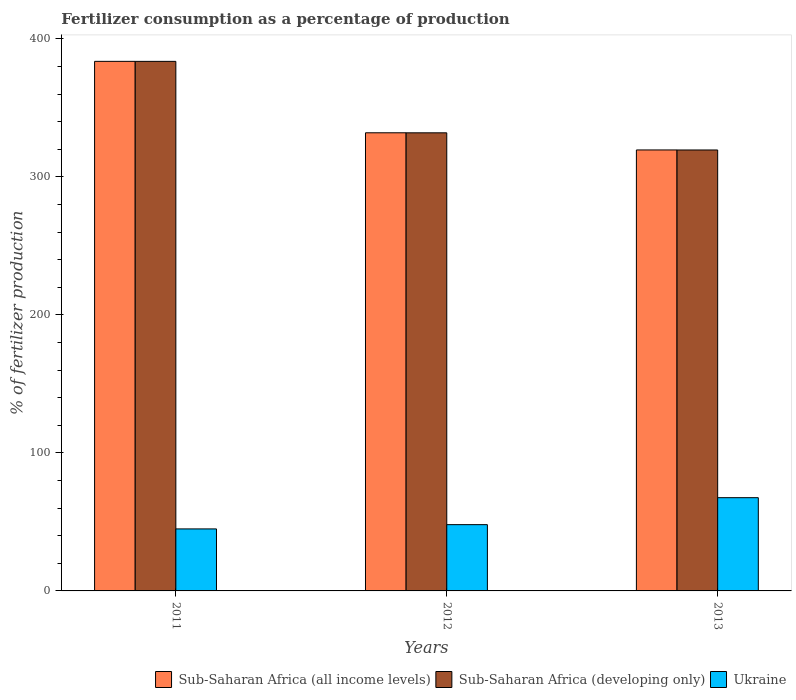How many different coloured bars are there?
Keep it short and to the point. 3. Are the number of bars per tick equal to the number of legend labels?
Your answer should be very brief. Yes. What is the percentage of fertilizers consumed in Sub-Saharan Africa (developing only) in 2012?
Provide a succinct answer. 331.91. Across all years, what is the maximum percentage of fertilizers consumed in Ukraine?
Make the answer very short. 67.55. Across all years, what is the minimum percentage of fertilizers consumed in Sub-Saharan Africa (developing only)?
Your response must be concise. 319.48. In which year was the percentage of fertilizers consumed in Sub-Saharan Africa (all income levels) maximum?
Offer a very short reply. 2011. What is the total percentage of fertilizers consumed in Sub-Saharan Africa (developing only) in the graph?
Your response must be concise. 1035.06. What is the difference between the percentage of fertilizers consumed in Sub-Saharan Africa (developing only) in 2011 and that in 2012?
Offer a very short reply. 51.77. What is the difference between the percentage of fertilizers consumed in Ukraine in 2011 and the percentage of fertilizers consumed in Sub-Saharan Africa (developing only) in 2012?
Offer a terse response. -286.99. What is the average percentage of fertilizers consumed in Sub-Saharan Africa (all income levels) per year?
Ensure brevity in your answer.  345.04. In the year 2011, what is the difference between the percentage of fertilizers consumed in Ukraine and percentage of fertilizers consumed in Sub-Saharan Africa (all income levels)?
Offer a terse response. -338.77. What is the ratio of the percentage of fertilizers consumed in Sub-Saharan Africa (all income levels) in 2011 to that in 2012?
Offer a very short reply. 1.16. Is the percentage of fertilizers consumed in Sub-Saharan Africa (developing only) in 2012 less than that in 2013?
Your answer should be very brief. No. What is the difference between the highest and the second highest percentage of fertilizers consumed in Ukraine?
Your answer should be compact. 19.53. What is the difference between the highest and the lowest percentage of fertilizers consumed in Sub-Saharan Africa (all income levels)?
Ensure brevity in your answer.  64.19. Is the sum of the percentage of fertilizers consumed in Ukraine in 2011 and 2012 greater than the maximum percentage of fertilizers consumed in Sub-Saharan Africa (all income levels) across all years?
Offer a terse response. No. What does the 3rd bar from the left in 2012 represents?
Provide a succinct answer. Ukraine. What does the 3rd bar from the right in 2011 represents?
Offer a very short reply. Sub-Saharan Africa (all income levels). Are all the bars in the graph horizontal?
Your answer should be compact. No. How many years are there in the graph?
Give a very brief answer. 3. Are the values on the major ticks of Y-axis written in scientific E-notation?
Ensure brevity in your answer.  No. What is the title of the graph?
Your answer should be compact. Fertilizer consumption as a percentage of production. Does "Latin America(developing only)" appear as one of the legend labels in the graph?
Ensure brevity in your answer.  No. What is the label or title of the X-axis?
Your answer should be very brief. Years. What is the label or title of the Y-axis?
Keep it short and to the point. % of fertilizer production. What is the % of fertilizer production of Sub-Saharan Africa (all income levels) in 2011?
Make the answer very short. 383.69. What is the % of fertilizer production in Sub-Saharan Africa (developing only) in 2011?
Your response must be concise. 383.68. What is the % of fertilizer production of Ukraine in 2011?
Offer a very short reply. 44.92. What is the % of fertilizer production of Sub-Saharan Africa (all income levels) in 2012?
Your response must be concise. 331.93. What is the % of fertilizer production in Sub-Saharan Africa (developing only) in 2012?
Your answer should be very brief. 331.91. What is the % of fertilizer production in Ukraine in 2012?
Your answer should be very brief. 48.02. What is the % of fertilizer production of Sub-Saharan Africa (all income levels) in 2013?
Provide a succinct answer. 319.5. What is the % of fertilizer production in Sub-Saharan Africa (developing only) in 2013?
Your answer should be compact. 319.48. What is the % of fertilizer production in Ukraine in 2013?
Provide a succinct answer. 67.55. Across all years, what is the maximum % of fertilizer production of Sub-Saharan Africa (all income levels)?
Make the answer very short. 383.69. Across all years, what is the maximum % of fertilizer production of Sub-Saharan Africa (developing only)?
Keep it short and to the point. 383.68. Across all years, what is the maximum % of fertilizer production in Ukraine?
Provide a succinct answer. 67.55. Across all years, what is the minimum % of fertilizer production of Sub-Saharan Africa (all income levels)?
Your response must be concise. 319.5. Across all years, what is the minimum % of fertilizer production of Sub-Saharan Africa (developing only)?
Give a very brief answer. 319.48. Across all years, what is the minimum % of fertilizer production in Ukraine?
Your response must be concise. 44.92. What is the total % of fertilizer production of Sub-Saharan Africa (all income levels) in the graph?
Provide a succinct answer. 1035.12. What is the total % of fertilizer production in Sub-Saharan Africa (developing only) in the graph?
Make the answer very short. 1035.06. What is the total % of fertilizer production of Ukraine in the graph?
Your response must be concise. 160.49. What is the difference between the % of fertilizer production in Sub-Saharan Africa (all income levels) in 2011 and that in 2012?
Make the answer very short. 51.76. What is the difference between the % of fertilizer production in Sub-Saharan Africa (developing only) in 2011 and that in 2012?
Your answer should be very brief. 51.77. What is the difference between the % of fertilizer production of Ukraine in 2011 and that in 2012?
Provide a short and direct response. -3.1. What is the difference between the % of fertilizer production in Sub-Saharan Africa (all income levels) in 2011 and that in 2013?
Your answer should be compact. 64.19. What is the difference between the % of fertilizer production in Sub-Saharan Africa (developing only) in 2011 and that in 2013?
Make the answer very short. 64.2. What is the difference between the % of fertilizer production in Ukraine in 2011 and that in 2013?
Provide a short and direct response. -22.63. What is the difference between the % of fertilizer production in Sub-Saharan Africa (all income levels) in 2012 and that in 2013?
Offer a terse response. 12.43. What is the difference between the % of fertilizer production of Sub-Saharan Africa (developing only) in 2012 and that in 2013?
Give a very brief answer. 12.43. What is the difference between the % of fertilizer production in Ukraine in 2012 and that in 2013?
Your answer should be very brief. -19.53. What is the difference between the % of fertilizer production in Sub-Saharan Africa (all income levels) in 2011 and the % of fertilizer production in Sub-Saharan Africa (developing only) in 2012?
Ensure brevity in your answer.  51.78. What is the difference between the % of fertilizer production of Sub-Saharan Africa (all income levels) in 2011 and the % of fertilizer production of Ukraine in 2012?
Your response must be concise. 335.67. What is the difference between the % of fertilizer production of Sub-Saharan Africa (developing only) in 2011 and the % of fertilizer production of Ukraine in 2012?
Offer a terse response. 335.66. What is the difference between the % of fertilizer production in Sub-Saharan Africa (all income levels) in 2011 and the % of fertilizer production in Sub-Saharan Africa (developing only) in 2013?
Your answer should be very brief. 64.21. What is the difference between the % of fertilizer production of Sub-Saharan Africa (all income levels) in 2011 and the % of fertilizer production of Ukraine in 2013?
Give a very brief answer. 316.14. What is the difference between the % of fertilizer production of Sub-Saharan Africa (developing only) in 2011 and the % of fertilizer production of Ukraine in 2013?
Your answer should be very brief. 316.12. What is the difference between the % of fertilizer production of Sub-Saharan Africa (all income levels) in 2012 and the % of fertilizer production of Sub-Saharan Africa (developing only) in 2013?
Your response must be concise. 12.45. What is the difference between the % of fertilizer production of Sub-Saharan Africa (all income levels) in 2012 and the % of fertilizer production of Ukraine in 2013?
Your response must be concise. 264.38. What is the difference between the % of fertilizer production of Sub-Saharan Africa (developing only) in 2012 and the % of fertilizer production of Ukraine in 2013?
Your response must be concise. 264.35. What is the average % of fertilizer production of Sub-Saharan Africa (all income levels) per year?
Keep it short and to the point. 345.04. What is the average % of fertilizer production in Sub-Saharan Africa (developing only) per year?
Offer a very short reply. 345.02. What is the average % of fertilizer production of Ukraine per year?
Your response must be concise. 53.5. In the year 2011, what is the difference between the % of fertilizer production in Sub-Saharan Africa (all income levels) and % of fertilizer production in Sub-Saharan Africa (developing only)?
Make the answer very short. 0.01. In the year 2011, what is the difference between the % of fertilizer production of Sub-Saharan Africa (all income levels) and % of fertilizer production of Ukraine?
Offer a very short reply. 338.77. In the year 2011, what is the difference between the % of fertilizer production of Sub-Saharan Africa (developing only) and % of fertilizer production of Ukraine?
Your response must be concise. 338.76. In the year 2012, what is the difference between the % of fertilizer production of Sub-Saharan Africa (all income levels) and % of fertilizer production of Sub-Saharan Africa (developing only)?
Your response must be concise. 0.02. In the year 2012, what is the difference between the % of fertilizer production in Sub-Saharan Africa (all income levels) and % of fertilizer production in Ukraine?
Offer a very short reply. 283.91. In the year 2012, what is the difference between the % of fertilizer production in Sub-Saharan Africa (developing only) and % of fertilizer production in Ukraine?
Make the answer very short. 283.89. In the year 2013, what is the difference between the % of fertilizer production of Sub-Saharan Africa (all income levels) and % of fertilizer production of Sub-Saharan Africa (developing only)?
Keep it short and to the point. 0.02. In the year 2013, what is the difference between the % of fertilizer production in Sub-Saharan Africa (all income levels) and % of fertilizer production in Ukraine?
Keep it short and to the point. 251.95. In the year 2013, what is the difference between the % of fertilizer production of Sub-Saharan Africa (developing only) and % of fertilizer production of Ukraine?
Offer a very short reply. 251.92. What is the ratio of the % of fertilizer production in Sub-Saharan Africa (all income levels) in 2011 to that in 2012?
Your answer should be very brief. 1.16. What is the ratio of the % of fertilizer production of Sub-Saharan Africa (developing only) in 2011 to that in 2012?
Make the answer very short. 1.16. What is the ratio of the % of fertilizer production in Ukraine in 2011 to that in 2012?
Keep it short and to the point. 0.94. What is the ratio of the % of fertilizer production of Sub-Saharan Africa (all income levels) in 2011 to that in 2013?
Your answer should be compact. 1.2. What is the ratio of the % of fertilizer production in Sub-Saharan Africa (developing only) in 2011 to that in 2013?
Ensure brevity in your answer.  1.2. What is the ratio of the % of fertilizer production of Ukraine in 2011 to that in 2013?
Ensure brevity in your answer.  0.67. What is the ratio of the % of fertilizer production in Sub-Saharan Africa (all income levels) in 2012 to that in 2013?
Keep it short and to the point. 1.04. What is the ratio of the % of fertilizer production in Sub-Saharan Africa (developing only) in 2012 to that in 2013?
Your response must be concise. 1.04. What is the ratio of the % of fertilizer production of Ukraine in 2012 to that in 2013?
Your answer should be compact. 0.71. What is the difference between the highest and the second highest % of fertilizer production of Sub-Saharan Africa (all income levels)?
Keep it short and to the point. 51.76. What is the difference between the highest and the second highest % of fertilizer production of Sub-Saharan Africa (developing only)?
Give a very brief answer. 51.77. What is the difference between the highest and the second highest % of fertilizer production of Ukraine?
Your answer should be very brief. 19.53. What is the difference between the highest and the lowest % of fertilizer production of Sub-Saharan Africa (all income levels)?
Ensure brevity in your answer.  64.19. What is the difference between the highest and the lowest % of fertilizer production in Sub-Saharan Africa (developing only)?
Your response must be concise. 64.2. What is the difference between the highest and the lowest % of fertilizer production of Ukraine?
Make the answer very short. 22.63. 